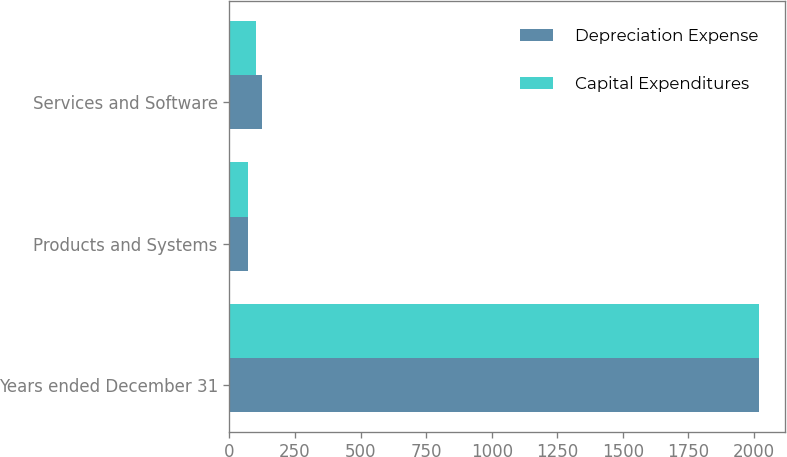<chart> <loc_0><loc_0><loc_500><loc_500><stacked_bar_chart><ecel><fcel>Years ended December 31<fcel>Products and Systems<fcel>Services and Software<nl><fcel>Depreciation Expense<fcel>2018<fcel>72<fcel>125<nl><fcel>Capital Expenditures<fcel>2018<fcel>71<fcel>101<nl></chart> 